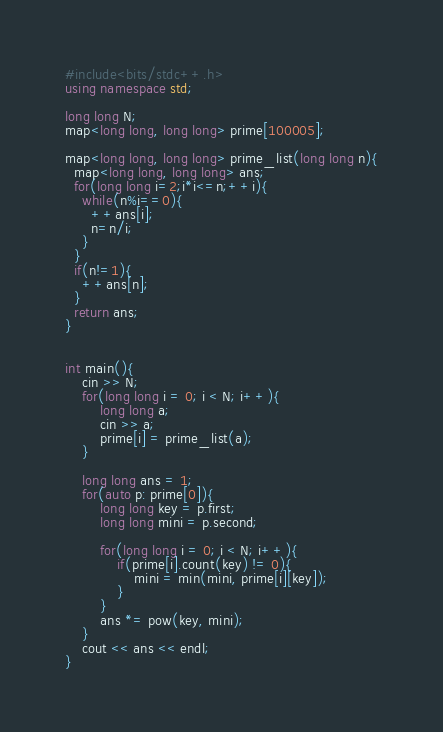<code> <loc_0><loc_0><loc_500><loc_500><_C++_>#include<bits/stdc++.h>
using namespace std;

long long N;
map<long long, long long> prime[100005];

map<long long, long long> prime_list(long long n){
  map<long long, long long> ans;
  for(long long i=2;i*i<=n;++i){
    while(n%i==0){
      ++ans[i];
      n=n/i;
    }
  }
  if(n!=1){
    ++ans[n];
  }
  return ans;
}


int main(){
	cin >> N;
	for(long long i = 0; i < N; i++){
		long long a;
		cin >> a;
		prime[i] = prime_list(a);
	}

	long long ans = 1;
	for(auto p: prime[0]){
		long long key = p.first;
		long long mini = p.second;

		for(long long i = 0; i < N; i++){
			if(prime[i].count(key) != 0){
				mini = min(mini, prime[i][key]);
			}
		}
		ans *= pow(key, mini);
	}
	cout << ans << endl;
}</code> 